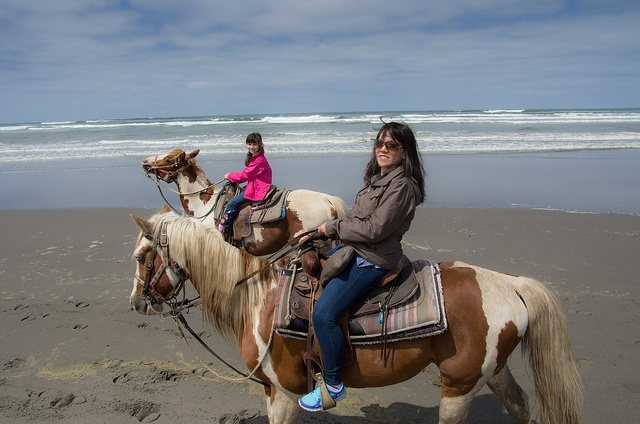Describe the objects in this image and their specific colors. I can see horse in gray, black, and maroon tones, people in gray, black, and navy tones, horse in gray, black, darkgray, and maroon tones, people in gray, black, purple, maroon, and brown tones, and handbag in gray and black tones in this image. 